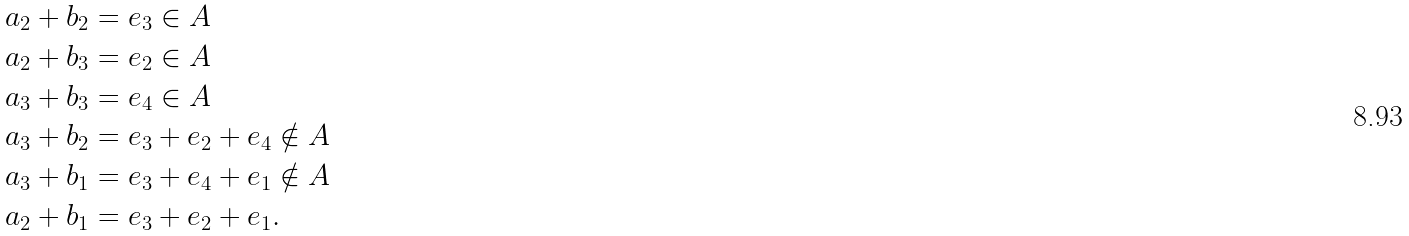Convert formula to latex. <formula><loc_0><loc_0><loc_500><loc_500>a _ { 2 } + b _ { 2 } & = e _ { 3 } \in A \\ a _ { 2 } + b _ { 3 } & = e _ { 2 } \in A \\ a _ { 3 } + b _ { 3 } & = e _ { 4 } \in A \\ a _ { 3 } + b _ { 2 } & = e _ { 3 } + e _ { 2 } + e _ { 4 } \notin A \\ a _ { 3 } + b _ { 1 } & = e _ { 3 } + e _ { 4 } + e _ { 1 } \notin A \\ a _ { 2 } + b _ { 1 } & = e _ { 3 } + e _ { 2 } + e _ { 1 } .</formula> 